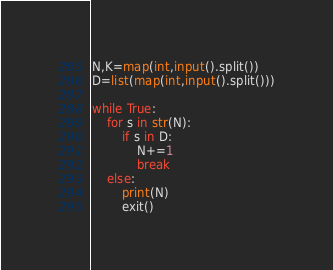<code> <loc_0><loc_0><loc_500><loc_500><_Python_>N,K=map(int,input().split())
D=list(map(int,input().split()))

while True:
    for s in str(N):
        if s in D:
            N+=1
            break
    else:
        print(N)
        exit()</code> 